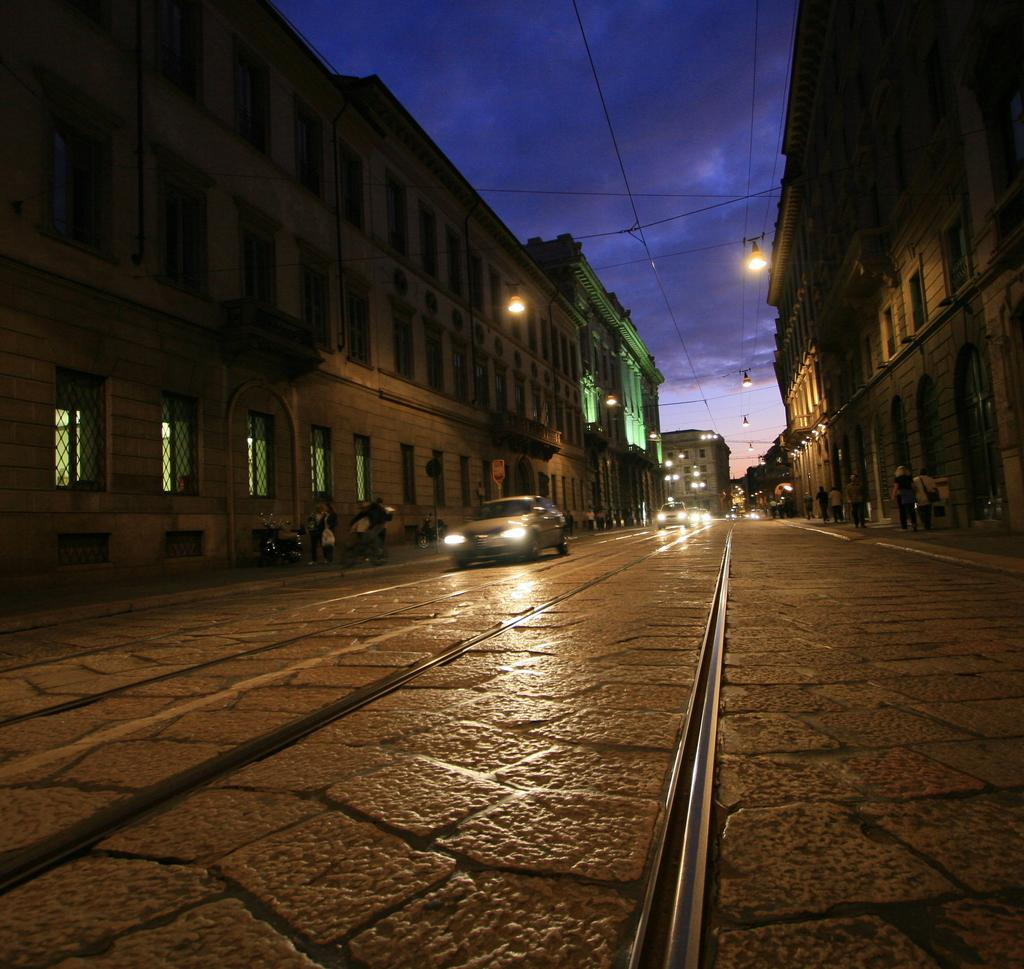What types of vehicles are on the road in the image? There are cars and bikes on the road in the image. Where are the cars and bikes located in the image? The cars and bikes are at the bottom of the image. What can be seen in the background of the image? There are buildings and lights in the background of the image. What is visible at the top of the image? The sky is visible at the top of the image. How many men are sitting on the straw in the image? There is no straw or men present in the image. What type of authority is depicted in the image? There is no authority figure depicted in the image; it features cars, bikes, buildings, lights, and the sky. 